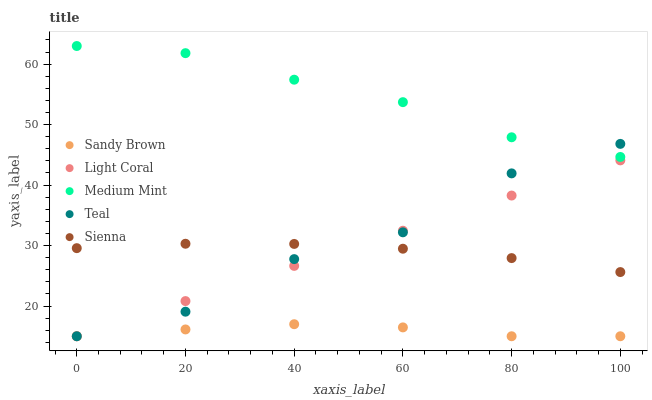Does Sandy Brown have the minimum area under the curve?
Answer yes or no. Yes. Does Medium Mint have the maximum area under the curve?
Answer yes or no. Yes. Does Medium Mint have the minimum area under the curve?
Answer yes or no. No. Does Sandy Brown have the maximum area under the curve?
Answer yes or no. No. Is Light Coral the smoothest?
Answer yes or no. Yes. Is Teal the roughest?
Answer yes or no. Yes. Is Medium Mint the smoothest?
Answer yes or no. No. Is Medium Mint the roughest?
Answer yes or no. No. Does Light Coral have the lowest value?
Answer yes or no. Yes. Does Medium Mint have the lowest value?
Answer yes or no. No. Does Medium Mint have the highest value?
Answer yes or no. Yes. Does Sandy Brown have the highest value?
Answer yes or no. No. Is Sandy Brown less than Sienna?
Answer yes or no. Yes. Is Medium Mint greater than Sandy Brown?
Answer yes or no. Yes. Does Sienna intersect Teal?
Answer yes or no. Yes. Is Sienna less than Teal?
Answer yes or no. No. Is Sienna greater than Teal?
Answer yes or no. No. Does Sandy Brown intersect Sienna?
Answer yes or no. No. 